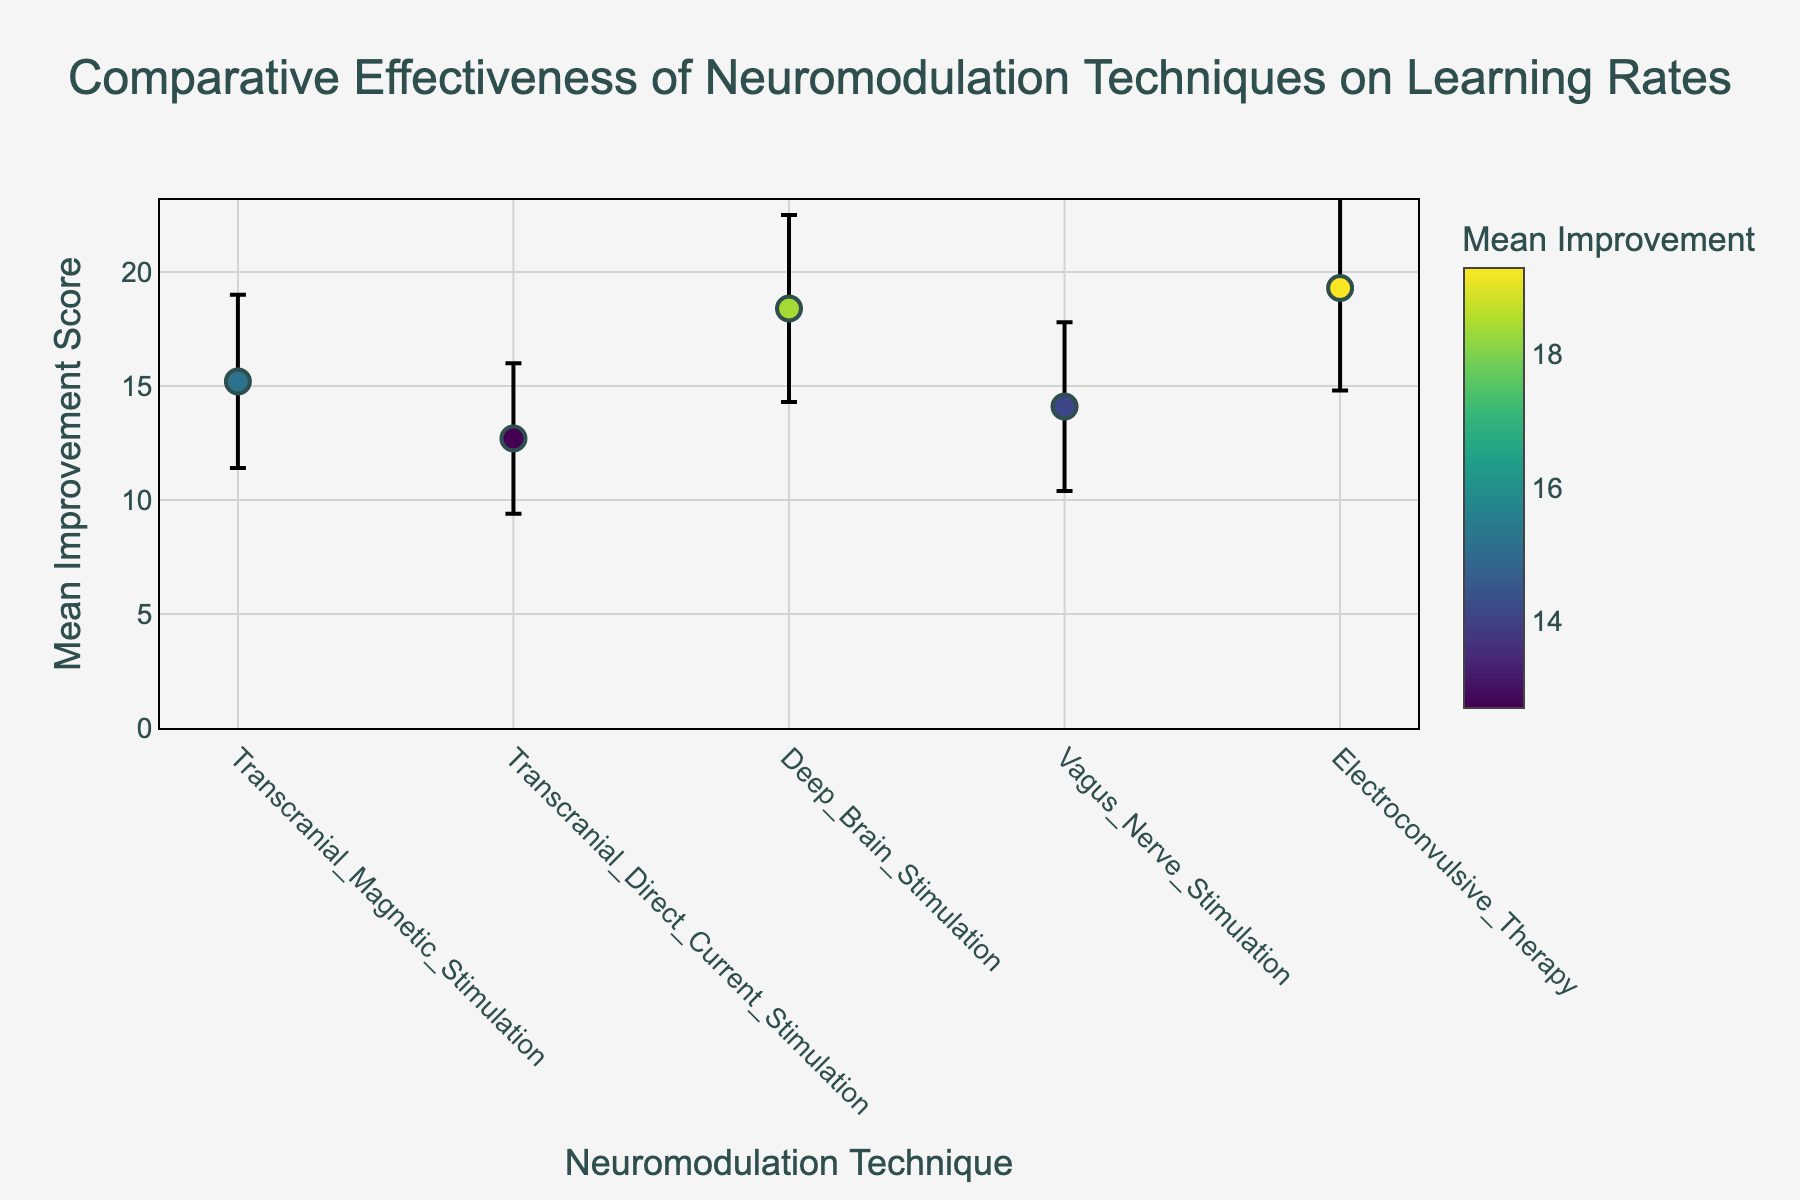What is the title of the figure? The title of a figure is usually located at the top and provides an overview of what the figure represents. In this case, it states the purpose of the comparison.
Answer: Comparative Effectiveness of Neuromodulation Techniques on Learning Rates Which neuromodulation technique has the highest mean improvement score? By looking at the y-values of the dots on the plot, we can identify the highest point. The highest mean improvement score is represented by the maximum y-value.
Answer: Electroconvulsive Therapy What is the range of the mean improvement scores displayed in the figure? To find the range, we need to subtract the lowest mean improvement score from the highest mean improvement score. The lowest is 12.7 (Transcranial Direct Current Stimulation) and the highest is 19.3 (Electroconvulsive Therapy). Therefore, 19.3 - 12.7 = 6.6.
Answer: 6.6 Which technique has the smallest standard deviation? The size of the error bars on the plot represents the standard deviation. The smallest error bar indicates the smallest standard deviation.
Answer: Transcranial Direct Current Stimulation How many neuromodulation techniques are compared in the figure? By counting the number of data points (dots on the plot) representing each technique, we get the total number of techniques compared.
Answer: Five Which techniques have mean improvement scores greater than 15? We look for dots that are positioned above the y-value of 15. The techniques associated with these dots are: Transcranial Magnetic Stimulation, Deep Brain Stimulation, and Electroconvulsive Therapy.
Answer: Transcranial Magnetic Stimulation, Deep Brain Stimulation, Electroconvulsive Therapy Which technique has a mean improvement score closest to the mean improvement score of Vagus Nerve Stimulation? Vagus Nerve Stimulation has a mean improvement score of 14.1. We find the mean improvement scores of other techniques and identify the one closest to 14.1, which is 15.2 for Transcranial Magnetic Stimulation.
Answer: Transcranial Magnetic Stimulation What is the difference in mean improvement scores between Deep Brain Stimulation and Transcranial Direct Current Stimulation? By subtracting the mean improvement score of Transcranial Direct Current Stimulation (12.7) from that of Deep Brain Stimulation (18.4), we get 18.4 - 12.7 = 5.7.
Answer: 5.7 Order the techniques from the highest to the lowest mean improvement score. To order the techniques, we list them based on their y-values (mean improvement scores) from highest to lowest. The order is: Electroconvulsive Therapy, Deep Brain Stimulation, Transcranial Magnetic Stimulation, Vagus Nerve Stimulation, Transcranial Direct Current Stimulation.
Answer: Electroconvulsive Therapy, Deep Brain Stimulation, Transcranial Magnetic Stimulation, Vagus Nerve Stimulation, Transcranial Direct Current Stimulation 